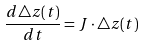<formula> <loc_0><loc_0><loc_500><loc_500>\frac { d \triangle z ( t ) } { d t } = J \cdot \triangle z ( t )</formula> 